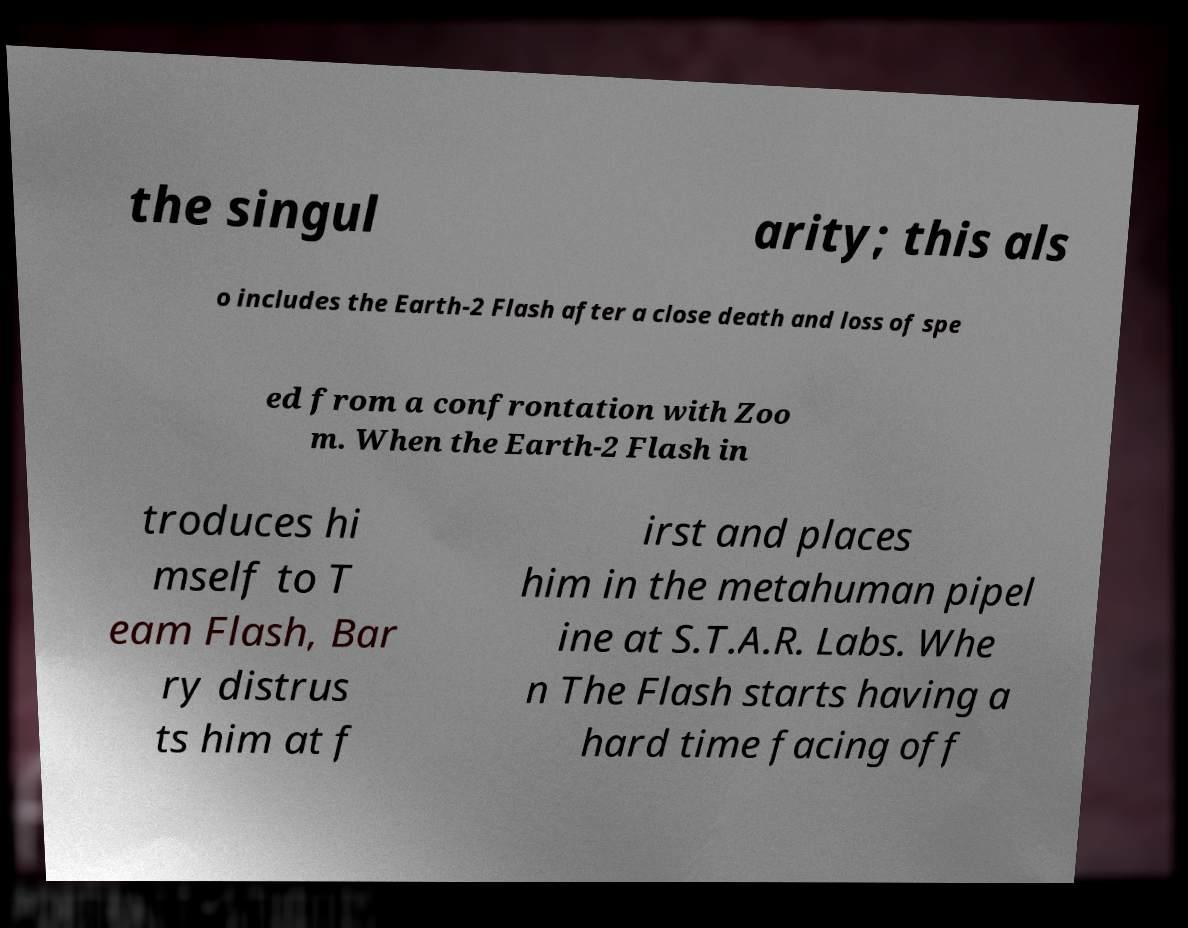Could you assist in decoding the text presented in this image and type it out clearly? the singul arity; this als o includes the Earth-2 Flash after a close death and loss of spe ed from a confrontation with Zoo m. When the Earth-2 Flash in troduces hi mself to T eam Flash, Bar ry distrus ts him at f irst and places him in the metahuman pipel ine at S.T.A.R. Labs. Whe n The Flash starts having a hard time facing off 